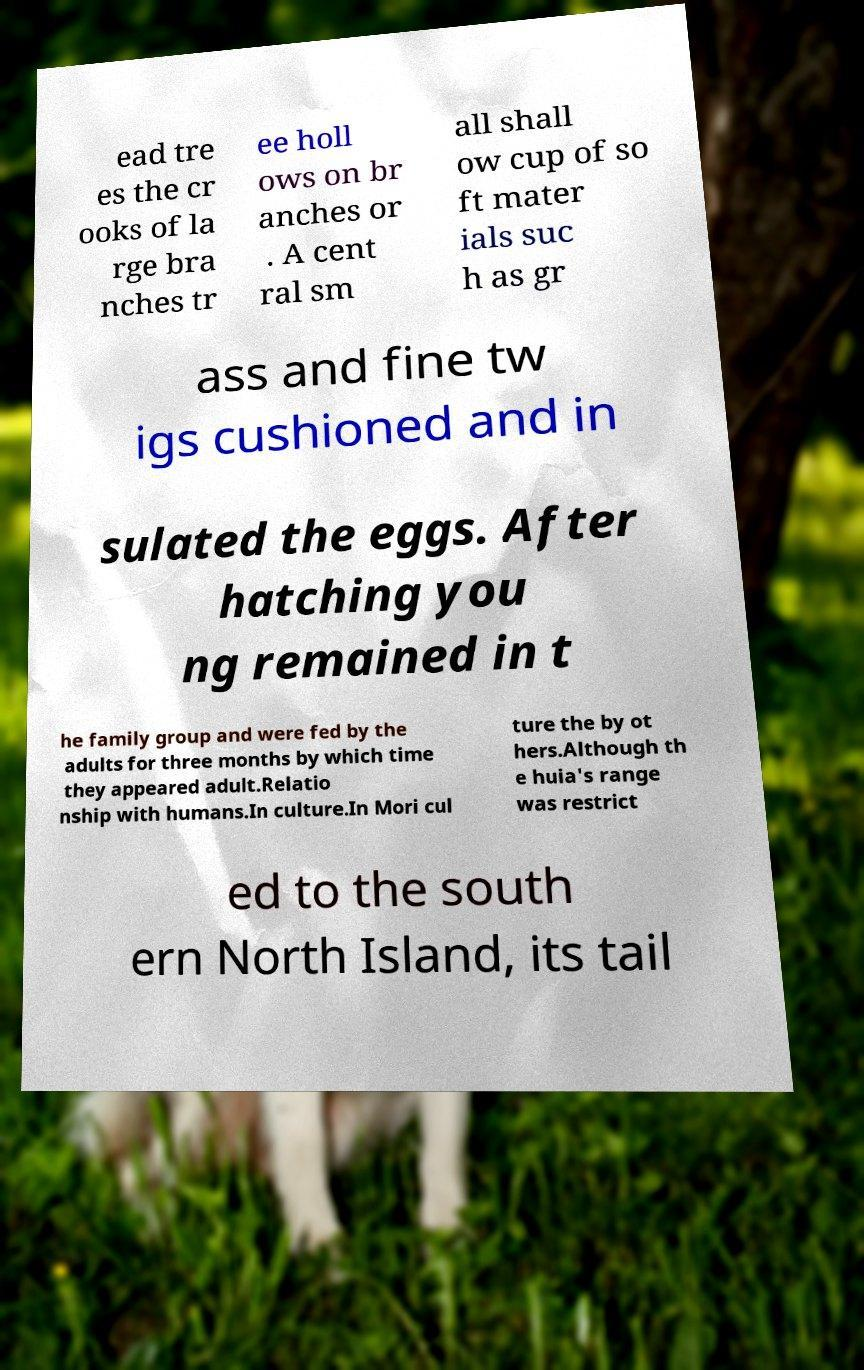For documentation purposes, I need the text within this image transcribed. Could you provide that? ead tre es the cr ooks of la rge bra nches tr ee holl ows on br anches or . A cent ral sm all shall ow cup of so ft mater ials suc h as gr ass and fine tw igs cushioned and in sulated the eggs. After hatching you ng remained in t he family group and were fed by the adults for three months by which time they appeared adult.Relatio nship with humans.In culture.In Mori cul ture the by ot hers.Although th e huia's range was restrict ed to the south ern North Island, its tail 